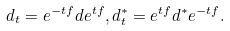Convert formula to latex. <formula><loc_0><loc_0><loc_500><loc_500>d _ { t } = e ^ { - t f } d e ^ { t f } , d _ { t } ^ { \ast } = e ^ { t f } d ^ { \ast } e ^ { - t f } .</formula> 